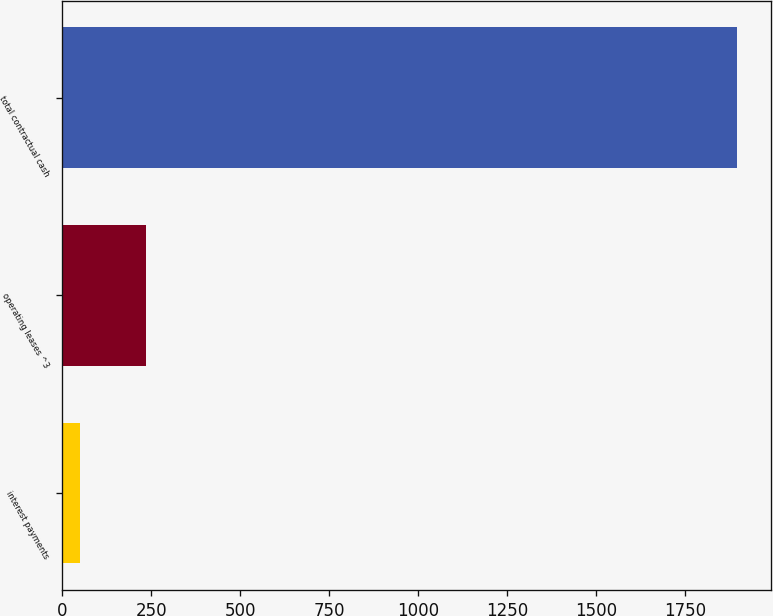Convert chart. <chart><loc_0><loc_0><loc_500><loc_500><bar_chart><fcel>interest payments<fcel>operating leases ^3<fcel>total contractual cash<nl><fcel>50<fcel>234.7<fcel>1897<nl></chart> 